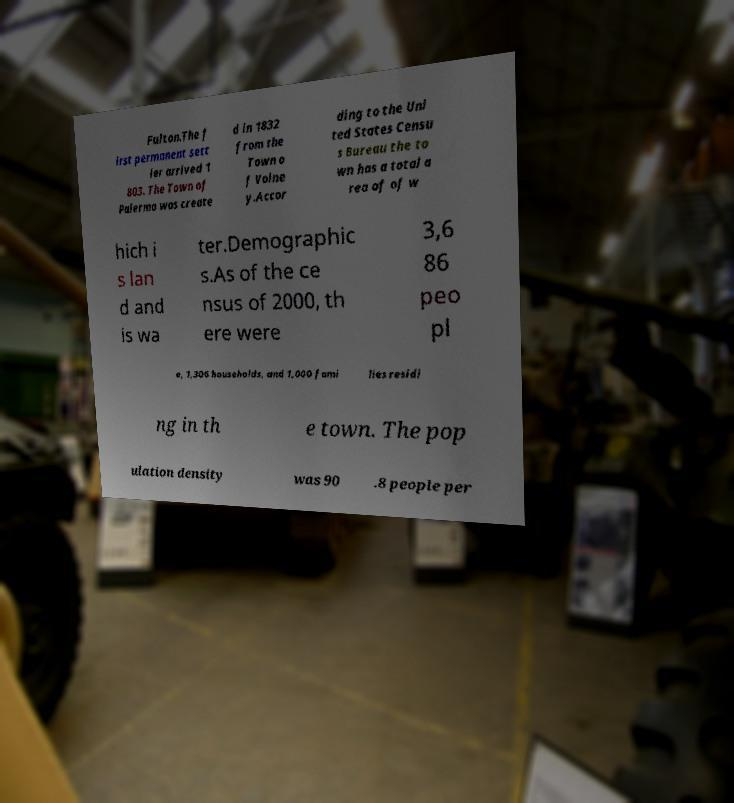What messages or text are displayed in this image? I need them in a readable, typed format. Fulton.The f irst permanent sett ler arrived 1 803. The Town of Palermo was create d in 1832 from the Town o f Volne y.Accor ding to the Uni ted States Censu s Bureau the to wn has a total a rea of of w hich i s lan d and is wa ter.Demographic s.As of the ce nsus of 2000, th ere were 3,6 86 peo pl e, 1,306 households, and 1,000 fami lies residi ng in th e town. The pop ulation density was 90 .8 people per 